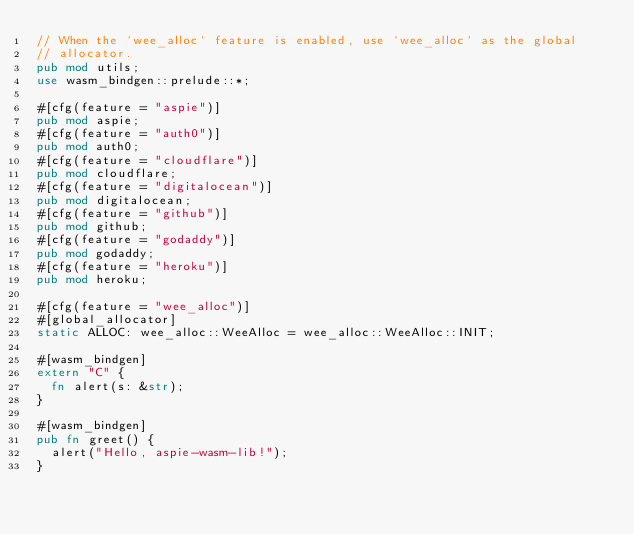Convert code to text. <code><loc_0><loc_0><loc_500><loc_500><_Rust_>// When the `wee_alloc` feature is enabled, use `wee_alloc` as the global
// allocator.
pub mod utils;
use wasm_bindgen::prelude::*;

#[cfg(feature = "aspie")]
pub mod aspie;
#[cfg(feature = "auth0")]
pub mod auth0;
#[cfg(feature = "cloudflare")]
pub mod cloudflare;
#[cfg(feature = "digitalocean")]
pub mod digitalocean;
#[cfg(feature = "github")]
pub mod github;
#[cfg(feature = "godaddy")]
pub mod godaddy;
#[cfg(feature = "heroku")]
pub mod heroku;

#[cfg(feature = "wee_alloc")]
#[global_allocator]
static ALLOC: wee_alloc::WeeAlloc = wee_alloc::WeeAlloc::INIT;

#[wasm_bindgen]
extern "C" {
  fn alert(s: &str);
}

#[wasm_bindgen]
pub fn greet() {
  alert("Hello, aspie-wasm-lib!");
}
</code> 